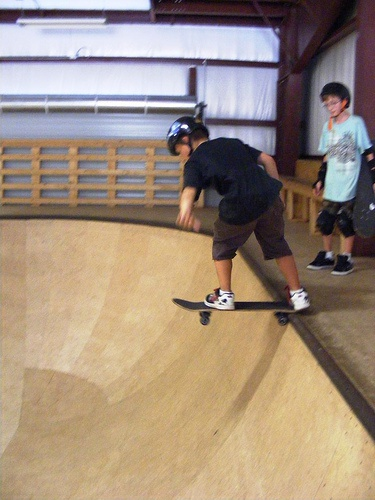Describe the objects in this image and their specific colors. I can see people in lavender, black, brown, gray, and maroon tones, people in lavender, black, lightblue, darkgray, and brown tones, bench in lavender, maroon, black, and gray tones, and skateboard in lavender, black, gray, and tan tones in this image. 